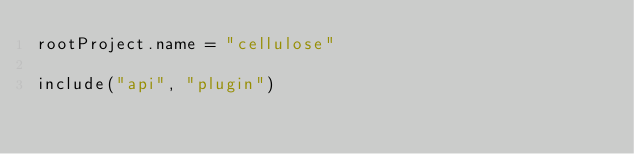<code> <loc_0><loc_0><loc_500><loc_500><_Kotlin_>rootProject.name = "cellulose"

include("api", "plugin")</code> 